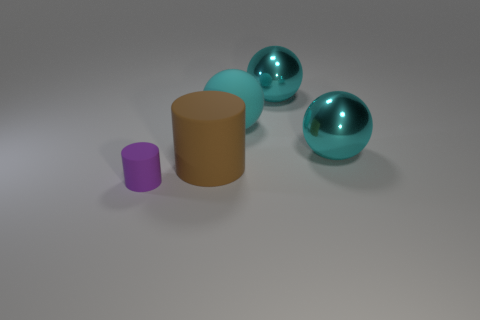Are there any metal objects that have the same color as the matte sphere?
Offer a very short reply. Yes. Is there a big cyan matte sphere?
Make the answer very short. Yes. Is the tiny thing the same shape as the big brown matte object?
Make the answer very short. Yes. What number of small objects are blue balls or brown things?
Provide a succinct answer. 0. The large matte cylinder has what color?
Offer a terse response. Brown. There is a cyan metal thing that is in front of the matte object on the right side of the brown matte cylinder; what is its shape?
Make the answer very short. Sphere. Are there any tiny green cubes made of the same material as the tiny object?
Provide a short and direct response. No. Is the size of the rubber object behind the brown thing the same as the small object?
Ensure brevity in your answer.  No. What number of red things are either big metal cubes or shiny balls?
Your response must be concise. 0. There is a big cyan object in front of the large cyan rubber object; what material is it?
Provide a short and direct response. Metal. 